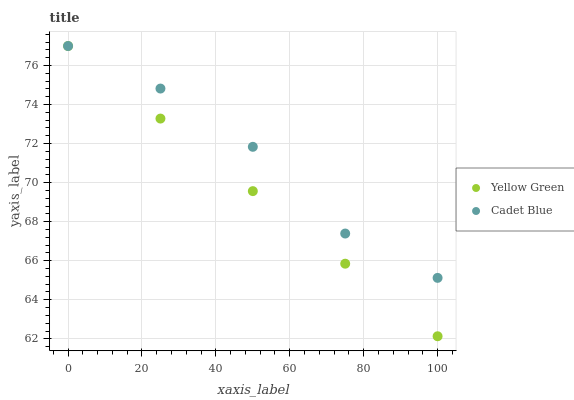Does Yellow Green have the minimum area under the curve?
Answer yes or no. Yes. Does Cadet Blue have the maximum area under the curve?
Answer yes or no. Yes. Does Yellow Green have the maximum area under the curve?
Answer yes or no. No. Is Yellow Green the smoothest?
Answer yes or no. Yes. Is Cadet Blue the roughest?
Answer yes or no. Yes. Is Yellow Green the roughest?
Answer yes or no. No. Does Yellow Green have the lowest value?
Answer yes or no. Yes. Does Yellow Green have the highest value?
Answer yes or no. Yes. Does Yellow Green intersect Cadet Blue?
Answer yes or no. Yes. Is Yellow Green less than Cadet Blue?
Answer yes or no. No. Is Yellow Green greater than Cadet Blue?
Answer yes or no. No. 